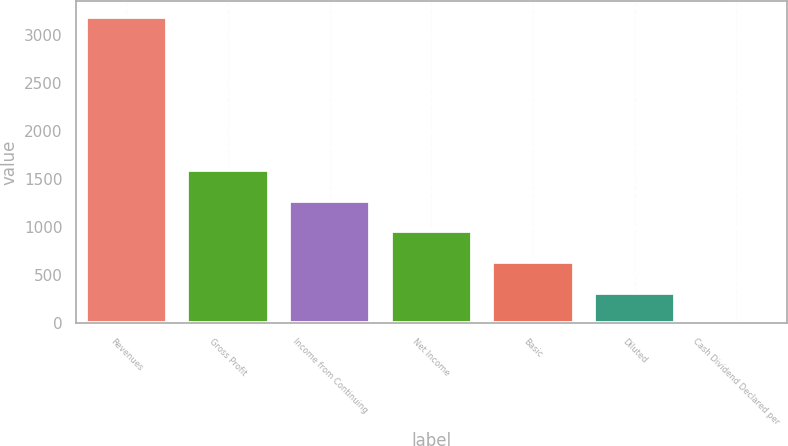<chart> <loc_0><loc_0><loc_500><loc_500><bar_chart><fcel>Revenues<fcel>Gross Profit<fcel>Income from Continuing<fcel>Net Income<fcel>Basic<fcel>Diluted<fcel>Cash Dividend Declared per<nl><fcel>3191.5<fcel>1595.81<fcel>1276.67<fcel>957.54<fcel>638.41<fcel>319.28<fcel>0.15<nl></chart> 